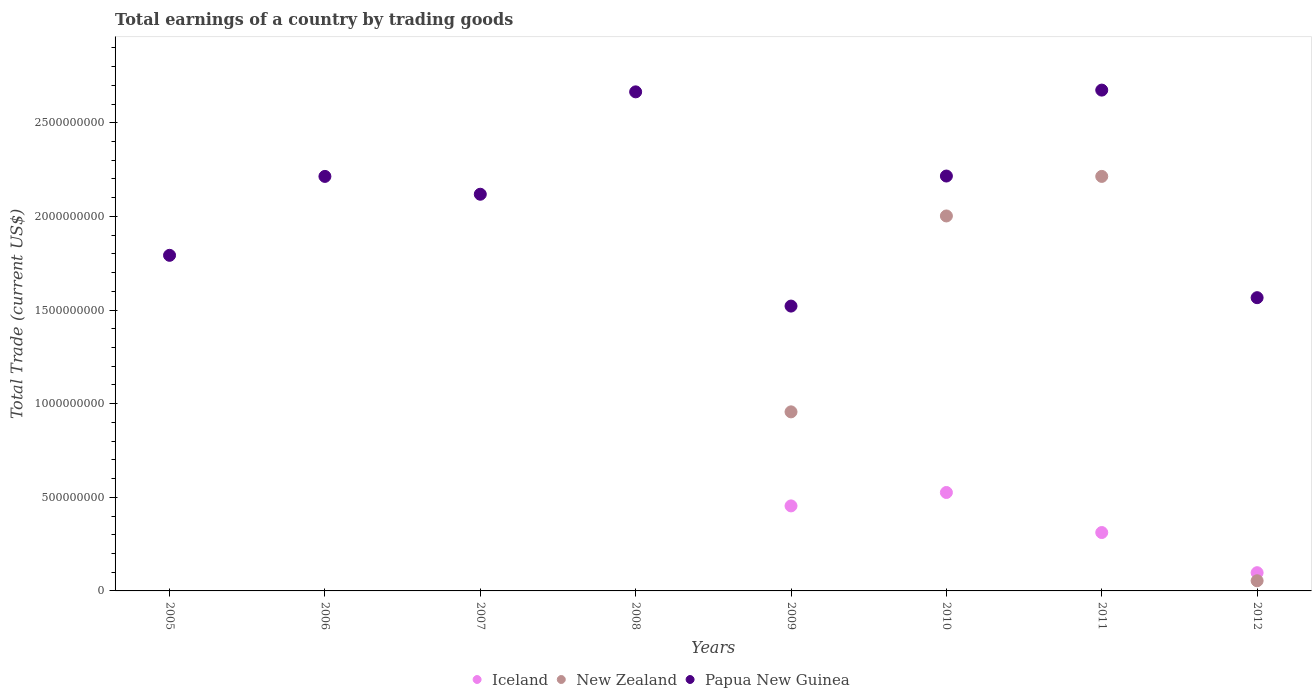How many different coloured dotlines are there?
Make the answer very short. 3. What is the total earnings in Papua New Guinea in 2007?
Provide a succinct answer. 2.12e+09. Across all years, what is the maximum total earnings in Iceland?
Your answer should be very brief. 5.26e+08. Across all years, what is the minimum total earnings in Iceland?
Your answer should be very brief. 0. In which year was the total earnings in Papua New Guinea maximum?
Offer a terse response. 2011. What is the total total earnings in New Zealand in the graph?
Keep it short and to the point. 5.23e+09. What is the difference between the total earnings in Papua New Guinea in 2011 and that in 2012?
Give a very brief answer. 1.11e+09. What is the difference between the total earnings in New Zealand in 2011 and the total earnings in Papua New Guinea in 2007?
Offer a terse response. 9.53e+07. What is the average total earnings in Iceland per year?
Keep it short and to the point. 1.74e+08. In the year 2012, what is the difference between the total earnings in Papua New Guinea and total earnings in Iceland?
Your answer should be very brief. 1.47e+09. In how many years, is the total earnings in Iceland greater than 2600000000 US$?
Provide a short and direct response. 0. What is the ratio of the total earnings in Iceland in 2011 to that in 2012?
Offer a very short reply. 3.2. Is the difference between the total earnings in Papua New Guinea in 2009 and 2012 greater than the difference between the total earnings in Iceland in 2009 and 2012?
Your answer should be very brief. No. What is the difference between the highest and the second highest total earnings in Papua New Guinea?
Offer a very short reply. 9.37e+06. What is the difference between the highest and the lowest total earnings in New Zealand?
Make the answer very short. 2.21e+09. In how many years, is the total earnings in Papua New Guinea greater than the average total earnings in Papua New Guinea taken over all years?
Offer a very short reply. 5. Does the total earnings in Iceland monotonically increase over the years?
Provide a succinct answer. No. Is the total earnings in New Zealand strictly greater than the total earnings in Papua New Guinea over the years?
Keep it short and to the point. No. Is the total earnings in Iceland strictly less than the total earnings in Papua New Guinea over the years?
Ensure brevity in your answer.  Yes. How many years are there in the graph?
Offer a terse response. 8. Does the graph contain grids?
Provide a short and direct response. No. How are the legend labels stacked?
Your answer should be very brief. Horizontal. What is the title of the graph?
Ensure brevity in your answer.  Total earnings of a country by trading goods. Does "Russian Federation" appear as one of the legend labels in the graph?
Make the answer very short. No. What is the label or title of the X-axis?
Your answer should be very brief. Years. What is the label or title of the Y-axis?
Your answer should be compact. Total Trade (current US$). What is the Total Trade (current US$) in Iceland in 2005?
Keep it short and to the point. 0. What is the Total Trade (current US$) of Papua New Guinea in 2005?
Give a very brief answer. 1.79e+09. What is the Total Trade (current US$) of Iceland in 2006?
Your answer should be compact. 0. What is the Total Trade (current US$) in New Zealand in 2006?
Your answer should be very brief. 0. What is the Total Trade (current US$) of Papua New Guinea in 2006?
Offer a very short reply. 2.21e+09. What is the Total Trade (current US$) in Papua New Guinea in 2007?
Provide a succinct answer. 2.12e+09. What is the Total Trade (current US$) of Iceland in 2008?
Provide a short and direct response. 0. What is the Total Trade (current US$) of Papua New Guinea in 2008?
Your response must be concise. 2.67e+09. What is the Total Trade (current US$) in Iceland in 2009?
Give a very brief answer. 4.54e+08. What is the Total Trade (current US$) in New Zealand in 2009?
Ensure brevity in your answer.  9.56e+08. What is the Total Trade (current US$) in Papua New Guinea in 2009?
Provide a succinct answer. 1.52e+09. What is the Total Trade (current US$) of Iceland in 2010?
Your answer should be very brief. 5.26e+08. What is the Total Trade (current US$) of New Zealand in 2010?
Provide a succinct answer. 2.00e+09. What is the Total Trade (current US$) in Papua New Guinea in 2010?
Ensure brevity in your answer.  2.22e+09. What is the Total Trade (current US$) of Iceland in 2011?
Offer a terse response. 3.12e+08. What is the Total Trade (current US$) in New Zealand in 2011?
Your response must be concise. 2.21e+09. What is the Total Trade (current US$) in Papua New Guinea in 2011?
Give a very brief answer. 2.67e+09. What is the Total Trade (current US$) in Iceland in 2012?
Make the answer very short. 9.74e+07. What is the Total Trade (current US$) of New Zealand in 2012?
Keep it short and to the point. 5.43e+07. What is the Total Trade (current US$) in Papua New Guinea in 2012?
Provide a short and direct response. 1.57e+09. Across all years, what is the maximum Total Trade (current US$) in Iceland?
Provide a short and direct response. 5.26e+08. Across all years, what is the maximum Total Trade (current US$) of New Zealand?
Keep it short and to the point. 2.21e+09. Across all years, what is the maximum Total Trade (current US$) in Papua New Guinea?
Your answer should be compact. 2.67e+09. Across all years, what is the minimum Total Trade (current US$) of Iceland?
Your answer should be very brief. 0. Across all years, what is the minimum Total Trade (current US$) in Papua New Guinea?
Make the answer very short. 1.52e+09. What is the total Total Trade (current US$) of Iceland in the graph?
Ensure brevity in your answer.  1.39e+09. What is the total Total Trade (current US$) in New Zealand in the graph?
Make the answer very short. 5.23e+09. What is the total Total Trade (current US$) in Papua New Guinea in the graph?
Make the answer very short. 1.68e+1. What is the difference between the Total Trade (current US$) of Papua New Guinea in 2005 and that in 2006?
Keep it short and to the point. -4.21e+08. What is the difference between the Total Trade (current US$) of Papua New Guinea in 2005 and that in 2007?
Ensure brevity in your answer.  -3.26e+08. What is the difference between the Total Trade (current US$) of Papua New Guinea in 2005 and that in 2008?
Your answer should be compact. -8.73e+08. What is the difference between the Total Trade (current US$) in Papua New Guinea in 2005 and that in 2009?
Keep it short and to the point. 2.71e+08. What is the difference between the Total Trade (current US$) of Papua New Guinea in 2005 and that in 2010?
Offer a terse response. -4.23e+08. What is the difference between the Total Trade (current US$) in Papua New Guinea in 2005 and that in 2011?
Keep it short and to the point. -8.82e+08. What is the difference between the Total Trade (current US$) of Papua New Guinea in 2005 and that in 2012?
Your response must be concise. 2.26e+08. What is the difference between the Total Trade (current US$) in Papua New Guinea in 2006 and that in 2007?
Your answer should be compact. 9.53e+07. What is the difference between the Total Trade (current US$) of Papua New Guinea in 2006 and that in 2008?
Your answer should be very brief. -4.52e+08. What is the difference between the Total Trade (current US$) of Papua New Guinea in 2006 and that in 2009?
Your answer should be very brief. 6.93e+08. What is the difference between the Total Trade (current US$) in Papua New Guinea in 2006 and that in 2010?
Offer a very short reply. -2.00e+06. What is the difference between the Total Trade (current US$) in Papua New Guinea in 2006 and that in 2011?
Make the answer very short. -4.61e+08. What is the difference between the Total Trade (current US$) of Papua New Guinea in 2006 and that in 2012?
Give a very brief answer. 6.48e+08. What is the difference between the Total Trade (current US$) of Papua New Guinea in 2007 and that in 2008?
Make the answer very short. -5.47e+08. What is the difference between the Total Trade (current US$) of Papua New Guinea in 2007 and that in 2009?
Your response must be concise. 5.97e+08. What is the difference between the Total Trade (current US$) in Papua New Guinea in 2007 and that in 2010?
Make the answer very short. -9.73e+07. What is the difference between the Total Trade (current US$) in Papua New Guinea in 2007 and that in 2011?
Your answer should be compact. -5.56e+08. What is the difference between the Total Trade (current US$) of Papua New Guinea in 2007 and that in 2012?
Provide a succinct answer. 5.52e+08. What is the difference between the Total Trade (current US$) of Papua New Guinea in 2008 and that in 2009?
Ensure brevity in your answer.  1.14e+09. What is the difference between the Total Trade (current US$) in Papua New Guinea in 2008 and that in 2010?
Give a very brief answer. 4.50e+08. What is the difference between the Total Trade (current US$) in Papua New Guinea in 2008 and that in 2011?
Give a very brief answer. -9.37e+06. What is the difference between the Total Trade (current US$) in Papua New Guinea in 2008 and that in 2012?
Your answer should be compact. 1.10e+09. What is the difference between the Total Trade (current US$) in Iceland in 2009 and that in 2010?
Provide a short and direct response. -7.16e+07. What is the difference between the Total Trade (current US$) of New Zealand in 2009 and that in 2010?
Keep it short and to the point. -1.05e+09. What is the difference between the Total Trade (current US$) in Papua New Guinea in 2009 and that in 2010?
Your response must be concise. -6.95e+08. What is the difference between the Total Trade (current US$) in Iceland in 2009 and that in 2011?
Provide a succinct answer. 1.42e+08. What is the difference between the Total Trade (current US$) of New Zealand in 2009 and that in 2011?
Offer a terse response. -1.26e+09. What is the difference between the Total Trade (current US$) of Papua New Guinea in 2009 and that in 2011?
Offer a very short reply. -1.15e+09. What is the difference between the Total Trade (current US$) in Iceland in 2009 and that in 2012?
Keep it short and to the point. 3.57e+08. What is the difference between the Total Trade (current US$) in New Zealand in 2009 and that in 2012?
Ensure brevity in your answer.  9.02e+08. What is the difference between the Total Trade (current US$) of Papua New Guinea in 2009 and that in 2012?
Your answer should be compact. -4.49e+07. What is the difference between the Total Trade (current US$) of Iceland in 2010 and that in 2011?
Your answer should be compact. 2.14e+08. What is the difference between the Total Trade (current US$) of New Zealand in 2010 and that in 2011?
Your answer should be very brief. -2.11e+08. What is the difference between the Total Trade (current US$) of Papua New Guinea in 2010 and that in 2011?
Provide a short and direct response. -4.59e+08. What is the difference between the Total Trade (current US$) of Iceland in 2010 and that in 2012?
Offer a terse response. 4.28e+08. What is the difference between the Total Trade (current US$) in New Zealand in 2010 and that in 2012?
Offer a very short reply. 1.95e+09. What is the difference between the Total Trade (current US$) of Papua New Guinea in 2010 and that in 2012?
Give a very brief answer. 6.50e+08. What is the difference between the Total Trade (current US$) in Iceland in 2011 and that in 2012?
Offer a very short reply. 2.14e+08. What is the difference between the Total Trade (current US$) in New Zealand in 2011 and that in 2012?
Ensure brevity in your answer.  2.16e+09. What is the difference between the Total Trade (current US$) in Papua New Guinea in 2011 and that in 2012?
Provide a succinct answer. 1.11e+09. What is the difference between the Total Trade (current US$) in Iceland in 2009 and the Total Trade (current US$) in New Zealand in 2010?
Provide a short and direct response. -1.55e+09. What is the difference between the Total Trade (current US$) in Iceland in 2009 and the Total Trade (current US$) in Papua New Guinea in 2010?
Offer a very short reply. -1.76e+09. What is the difference between the Total Trade (current US$) of New Zealand in 2009 and the Total Trade (current US$) of Papua New Guinea in 2010?
Give a very brief answer. -1.26e+09. What is the difference between the Total Trade (current US$) in Iceland in 2009 and the Total Trade (current US$) in New Zealand in 2011?
Provide a short and direct response. -1.76e+09. What is the difference between the Total Trade (current US$) in Iceland in 2009 and the Total Trade (current US$) in Papua New Guinea in 2011?
Give a very brief answer. -2.22e+09. What is the difference between the Total Trade (current US$) of New Zealand in 2009 and the Total Trade (current US$) of Papua New Guinea in 2011?
Ensure brevity in your answer.  -1.72e+09. What is the difference between the Total Trade (current US$) in Iceland in 2009 and the Total Trade (current US$) in New Zealand in 2012?
Offer a terse response. 4.00e+08. What is the difference between the Total Trade (current US$) in Iceland in 2009 and the Total Trade (current US$) in Papua New Guinea in 2012?
Make the answer very short. -1.11e+09. What is the difference between the Total Trade (current US$) in New Zealand in 2009 and the Total Trade (current US$) in Papua New Guinea in 2012?
Offer a terse response. -6.10e+08. What is the difference between the Total Trade (current US$) in Iceland in 2010 and the Total Trade (current US$) in New Zealand in 2011?
Provide a succinct answer. -1.69e+09. What is the difference between the Total Trade (current US$) of Iceland in 2010 and the Total Trade (current US$) of Papua New Guinea in 2011?
Give a very brief answer. -2.15e+09. What is the difference between the Total Trade (current US$) in New Zealand in 2010 and the Total Trade (current US$) in Papua New Guinea in 2011?
Provide a short and direct response. -6.72e+08. What is the difference between the Total Trade (current US$) in Iceland in 2010 and the Total Trade (current US$) in New Zealand in 2012?
Your response must be concise. 4.71e+08. What is the difference between the Total Trade (current US$) in Iceland in 2010 and the Total Trade (current US$) in Papua New Guinea in 2012?
Keep it short and to the point. -1.04e+09. What is the difference between the Total Trade (current US$) in New Zealand in 2010 and the Total Trade (current US$) in Papua New Guinea in 2012?
Your answer should be compact. 4.36e+08. What is the difference between the Total Trade (current US$) of Iceland in 2011 and the Total Trade (current US$) of New Zealand in 2012?
Your answer should be compact. 2.58e+08. What is the difference between the Total Trade (current US$) of Iceland in 2011 and the Total Trade (current US$) of Papua New Guinea in 2012?
Keep it short and to the point. -1.25e+09. What is the difference between the Total Trade (current US$) of New Zealand in 2011 and the Total Trade (current US$) of Papua New Guinea in 2012?
Offer a terse response. 6.48e+08. What is the average Total Trade (current US$) in Iceland per year?
Your answer should be very brief. 1.74e+08. What is the average Total Trade (current US$) in New Zealand per year?
Your answer should be compact. 6.53e+08. What is the average Total Trade (current US$) of Papua New Guinea per year?
Your answer should be very brief. 2.10e+09. In the year 2009, what is the difference between the Total Trade (current US$) in Iceland and Total Trade (current US$) in New Zealand?
Offer a very short reply. -5.02e+08. In the year 2009, what is the difference between the Total Trade (current US$) of Iceland and Total Trade (current US$) of Papua New Guinea?
Your answer should be compact. -1.07e+09. In the year 2009, what is the difference between the Total Trade (current US$) in New Zealand and Total Trade (current US$) in Papua New Guinea?
Provide a short and direct response. -5.65e+08. In the year 2010, what is the difference between the Total Trade (current US$) in Iceland and Total Trade (current US$) in New Zealand?
Give a very brief answer. -1.48e+09. In the year 2010, what is the difference between the Total Trade (current US$) of Iceland and Total Trade (current US$) of Papua New Guinea?
Provide a succinct answer. -1.69e+09. In the year 2010, what is the difference between the Total Trade (current US$) in New Zealand and Total Trade (current US$) in Papua New Guinea?
Ensure brevity in your answer.  -2.13e+08. In the year 2011, what is the difference between the Total Trade (current US$) of Iceland and Total Trade (current US$) of New Zealand?
Ensure brevity in your answer.  -1.90e+09. In the year 2011, what is the difference between the Total Trade (current US$) of Iceland and Total Trade (current US$) of Papua New Guinea?
Offer a very short reply. -2.36e+09. In the year 2011, what is the difference between the Total Trade (current US$) of New Zealand and Total Trade (current US$) of Papua New Guinea?
Your response must be concise. -4.61e+08. In the year 2012, what is the difference between the Total Trade (current US$) of Iceland and Total Trade (current US$) of New Zealand?
Provide a short and direct response. 4.31e+07. In the year 2012, what is the difference between the Total Trade (current US$) in Iceland and Total Trade (current US$) in Papua New Guinea?
Give a very brief answer. -1.47e+09. In the year 2012, what is the difference between the Total Trade (current US$) in New Zealand and Total Trade (current US$) in Papua New Guinea?
Keep it short and to the point. -1.51e+09. What is the ratio of the Total Trade (current US$) of Papua New Guinea in 2005 to that in 2006?
Your response must be concise. 0.81. What is the ratio of the Total Trade (current US$) of Papua New Guinea in 2005 to that in 2007?
Your answer should be very brief. 0.85. What is the ratio of the Total Trade (current US$) of Papua New Guinea in 2005 to that in 2008?
Make the answer very short. 0.67. What is the ratio of the Total Trade (current US$) in Papua New Guinea in 2005 to that in 2009?
Your response must be concise. 1.18. What is the ratio of the Total Trade (current US$) of Papua New Guinea in 2005 to that in 2010?
Give a very brief answer. 0.81. What is the ratio of the Total Trade (current US$) of Papua New Guinea in 2005 to that in 2011?
Offer a very short reply. 0.67. What is the ratio of the Total Trade (current US$) of Papua New Guinea in 2005 to that in 2012?
Ensure brevity in your answer.  1.14. What is the ratio of the Total Trade (current US$) in Papua New Guinea in 2006 to that in 2007?
Give a very brief answer. 1.04. What is the ratio of the Total Trade (current US$) in Papua New Guinea in 2006 to that in 2008?
Ensure brevity in your answer.  0.83. What is the ratio of the Total Trade (current US$) in Papua New Guinea in 2006 to that in 2009?
Offer a very short reply. 1.46. What is the ratio of the Total Trade (current US$) in Papua New Guinea in 2006 to that in 2010?
Keep it short and to the point. 1. What is the ratio of the Total Trade (current US$) in Papua New Guinea in 2006 to that in 2011?
Keep it short and to the point. 0.83. What is the ratio of the Total Trade (current US$) in Papua New Guinea in 2006 to that in 2012?
Give a very brief answer. 1.41. What is the ratio of the Total Trade (current US$) of Papua New Guinea in 2007 to that in 2008?
Provide a succinct answer. 0.79. What is the ratio of the Total Trade (current US$) of Papua New Guinea in 2007 to that in 2009?
Provide a succinct answer. 1.39. What is the ratio of the Total Trade (current US$) of Papua New Guinea in 2007 to that in 2010?
Provide a succinct answer. 0.96. What is the ratio of the Total Trade (current US$) in Papua New Guinea in 2007 to that in 2011?
Provide a short and direct response. 0.79. What is the ratio of the Total Trade (current US$) in Papua New Guinea in 2007 to that in 2012?
Provide a succinct answer. 1.35. What is the ratio of the Total Trade (current US$) in Papua New Guinea in 2008 to that in 2009?
Offer a terse response. 1.75. What is the ratio of the Total Trade (current US$) in Papua New Guinea in 2008 to that in 2010?
Provide a succinct answer. 1.2. What is the ratio of the Total Trade (current US$) of Papua New Guinea in 2008 to that in 2011?
Your response must be concise. 1. What is the ratio of the Total Trade (current US$) of Papua New Guinea in 2008 to that in 2012?
Your answer should be compact. 1.7. What is the ratio of the Total Trade (current US$) in Iceland in 2009 to that in 2010?
Provide a succinct answer. 0.86. What is the ratio of the Total Trade (current US$) in New Zealand in 2009 to that in 2010?
Keep it short and to the point. 0.48. What is the ratio of the Total Trade (current US$) in Papua New Guinea in 2009 to that in 2010?
Offer a very short reply. 0.69. What is the ratio of the Total Trade (current US$) of Iceland in 2009 to that in 2011?
Provide a succinct answer. 1.46. What is the ratio of the Total Trade (current US$) of New Zealand in 2009 to that in 2011?
Ensure brevity in your answer.  0.43. What is the ratio of the Total Trade (current US$) of Papua New Guinea in 2009 to that in 2011?
Offer a terse response. 0.57. What is the ratio of the Total Trade (current US$) of Iceland in 2009 to that in 2012?
Keep it short and to the point. 4.66. What is the ratio of the Total Trade (current US$) of New Zealand in 2009 to that in 2012?
Your answer should be compact. 17.62. What is the ratio of the Total Trade (current US$) in Papua New Guinea in 2009 to that in 2012?
Provide a short and direct response. 0.97. What is the ratio of the Total Trade (current US$) of Iceland in 2010 to that in 2011?
Provide a succinct answer. 1.69. What is the ratio of the Total Trade (current US$) of New Zealand in 2010 to that in 2011?
Make the answer very short. 0.9. What is the ratio of the Total Trade (current US$) in Papua New Guinea in 2010 to that in 2011?
Offer a very short reply. 0.83. What is the ratio of the Total Trade (current US$) of Iceland in 2010 to that in 2012?
Keep it short and to the point. 5.4. What is the ratio of the Total Trade (current US$) of New Zealand in 2010 to that in 2012?
Your response must be concise. 36.89. What is the ratio of the Total Trade (current US$) of Papua New Guinea in 2010 to that in 2012?
Your answer should be compact. 1.41. What is the ratio of the Total Trade (current US$) of Iceland in 2011 to that in 2012?
Your response must be concise. 3.2. What is the ratio of the Total Trade (current US$) in New Zealand in 2011 to that in 2012?
Offer a very short reply. 40.78. What is the ratio of the Total Trade (current US$) in Papua New Guinea in 2011 to that in 2012?
Your answer should be very brief. 1.71. What is the difference between the highest and the second highest Total Trade (current US$) in Iceland?
Offer a very short reply. 7.16e+07. What is the difference between the highest and the second highest Total Trade (current US$) in New Zealand?
Give a very brief answer. 2.11e+08. What is the difference between the highest and the second highest Total Trade (current US$) of Papua New Guinea?
Your response must be concise. 9.37e+06. What is the difference between the highest and the lowest Total Trade (current US$) of Iceland?
Your response must be concise. 5.26e+08. What is the difference between the highest and the lowest Total Trade (current US$) in New Zealand?
Give a very brief answer. 2.21e+09. What is the difference between the highest and the lowest Total Trade (current US$) of Papua New Guinea?
Offer a very short reply. 1.15e+09. 